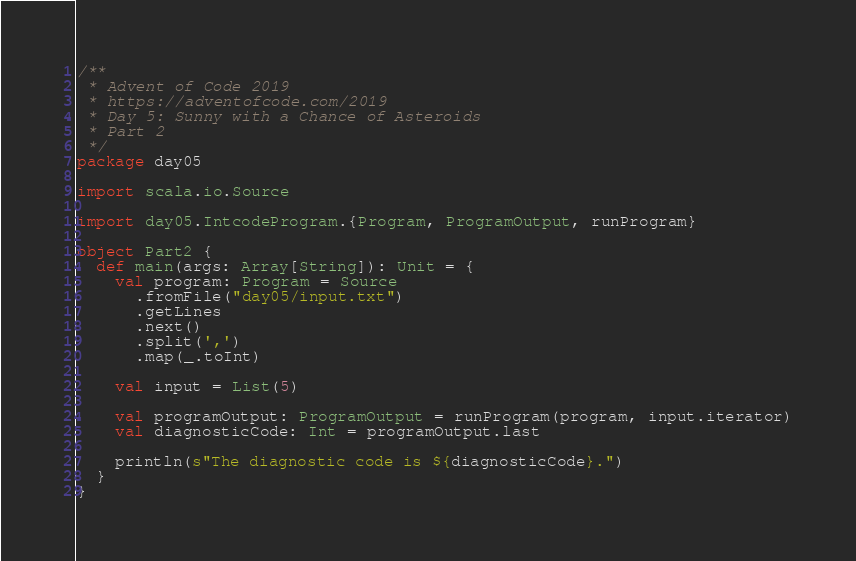Convert code to text. <code><loc_0><loc_0><loc_500><loc_500><_Scala_>/**
 * Advent of Code 2019
 * https://adventofcode.com/2019
 * Day 5: Sunny with a Chance of Asteroids
 * Part 2
 */
package day05

import scala.io.Source

import day05.IntcodeProgram.{Program, ProgramOutput, runProgram}

object Part2 {
  def main(args: Array[String]): Unit = {
    val program: Program = Source
      .fromFile("day05/input.txt")
      .getLines
      .next()
      .split(',')
      .map(_.toInt)

    val input = List(5)

    val programOutput: ProgramOutput = runProgram(program, input.iterator)
    val diagnosticCode: Int = programOutput.last

    println(s"The diagnostic code is ${diagnosticCode}.")
  }
}
</code> 